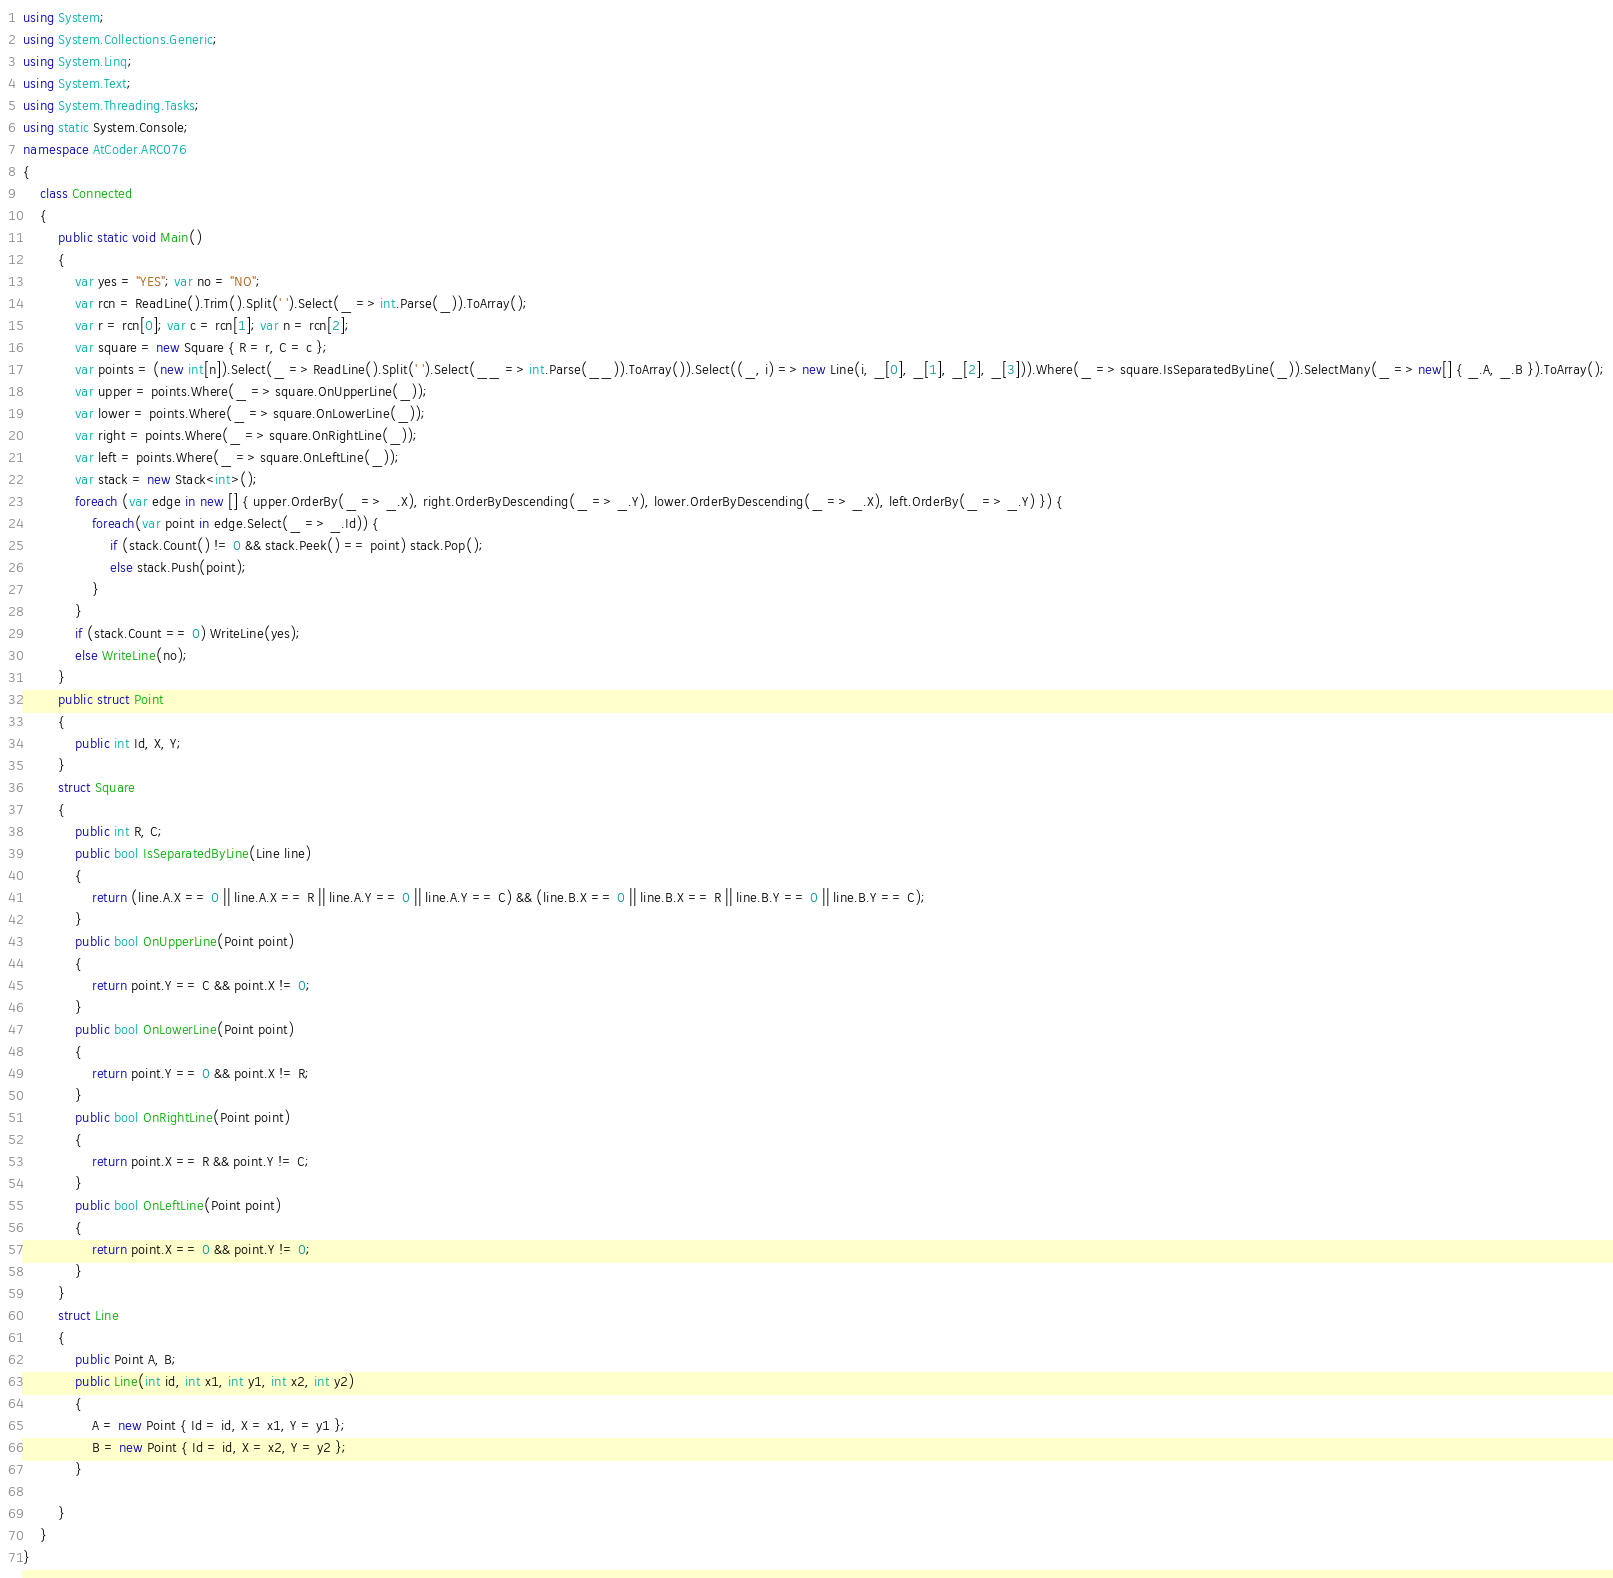<code> <loc_0><loc_0><loc_500><loc_500><_C#_>using System;
using System.Collections.Generic;
using System.Linq;
using System.Text;
using System.Threading.Tasks;
using static System.Console;
namespace AtCoder.ARC076
{
    class Connected
    {
        public static void Main()
        {
            var yes = "YES"; var no = "NO";
            var rcn = ReadLine().Trim().Split(' ').Select(_ => int.Parse(_)).ToArray();
            var r = rcn[0]; var c = rcn[1]; var n = rcn[2];
            var square = new Square { R = r, C = c };
            var points = (new int[n]).Select(_ => ReadLine().Split(' ').Select(__ => int.Parse(__)).ToArray()).Select((_, i) => new Line(i, _[0], _[1], _[2], _[3])).Where(_ => square.IsSeparatedByLine(_)).SelectMany(_ => new[] { _.A, _.B }).ToArray();
            var upper = points.Where(_ => square.OnUpperLine(_));
            var lower = points.Where(_ => square.OnLowerLine(_));
            var right = points.Where(_ => square.OnRightLine(_));
            var left = points.Where(_ => square.OnLeftLine(_));
            var stack = new Stack<int>();
            foreach (var edge in new [] { upper.OrderBy(_ => _.X), right.OrderByDescending(_ => _.Y), lower.OrderByDescending(_ => _.X), left.OrderBy(_ => _.Y) }) {
                foreach(var point in edge.Select(_ => _.Id)) {
                    if (stack.Count() != 0 && stack.Peek() == point) stack.Pop();
                    else stack.Push(point);
                }
            }
            if (stack.Count == 0) WriteLine(yes);
            else WriteLine(no);
        }
        public struct Point
        {
            public int Id, X, Y;
        }
        struct Square
        {
            public int R, C;
            public bool IsSeparatedByLine(Line line)
            {
                return (line.A.X == 0 || line.A.X == R || line.A.Y == 0 || line.A.Y == C) && (line.B.X == 0 || line.B.X == R || line.B.Y == 0 || line.B.Y == C);
            }
            public bool OnUpperLine(Point point)
            {
                return point.Y == C && point.X != 0;
            }
            public bool OnLowerLine(Point point)
            {
                return point.Y == 0 && point.X != R;
            }
            public bool OnRightLine(Point point)
            {
                return point.X == R && point.Y != C;
            }
            public bool OnLeftLine(Point point)
            {
                return point.X == 0 && point.Y != 0;
            }
        }
        struct Line
        {
            public Point A, B;
            public Line(int id, int x1, int y1, int x2, int y2)
            {
                A = new Point { Id = id, X = x1, Y = y1 };
                B = new Point { Id = id, X = x2, Y = y2 };
            }

        }
    }
}
</code> 